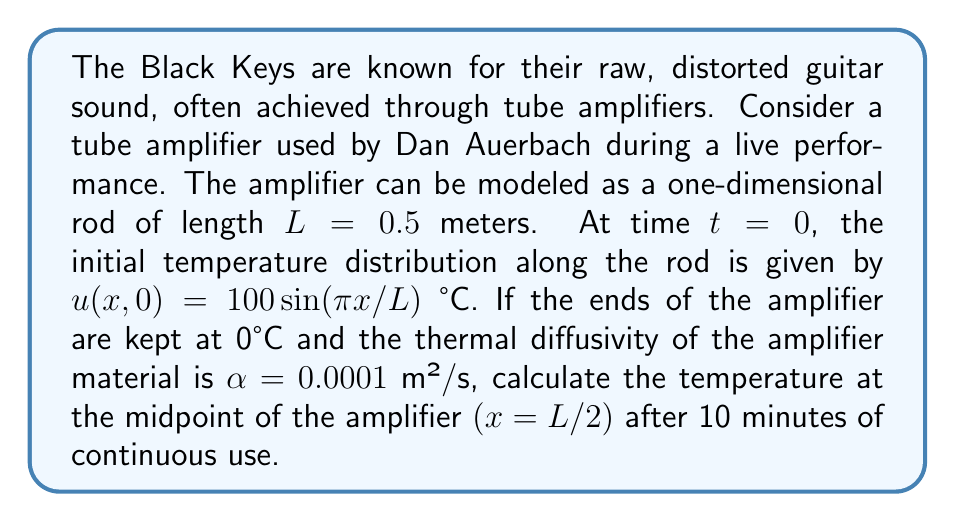Show me your answer to this math problem. To solve this problem, we'll use the heat equation in one dimension:

$$\frac{\partial u}{\partial t} = \alpha \frac{\partial^2 u}{\partial x^2}$$

Given the boundary conditions (ends kept at 0°C) and the initial condition, we can use the method of separation of variables to find the solution.

Step 1: The general solution for this problem is of the form:
$$u(x,t) = \sum_{n=1}^{\infty} B_n \sin\left(\frac{n\pi x}{L}\right)e^{-\alpha(\frac{n\pi}{L})^2t}$$

Step 2: The initial condition matches the first term of this series $(n=1)$, so we only need to consider:
$$u(x,t) = 100 \sin\left(\frac{\pi x}{L}\right)e^{-\alpha(\frac{\pi}{L})^2t}$$

Step 3: Calculate the temperature at the midpoint $(x = L/2)$ after 10 minutes $(t = 600s)$:
$$u(L/2, 600) = 100 \sin\left(\frac{\pi (L/2)}{L}\right)e^{-\alpha(\frac{\pi}{L})^2(600)}$$

Step 4: Simplify:
$$u(L/2, 600) = 100 \sin\left(\frac{\pi}{2}\right)e^{-0.0001(\frac{\pi}{0.5})^2(600)}$$

Step 5: Calculate:
$$u(L/2, 600) = 100 \cdot 1 \cdot e^{-0.0001 \cdot 39.4784 \cdot 600} \approx 9.12°C$$
Answer: $9.12°C$ 